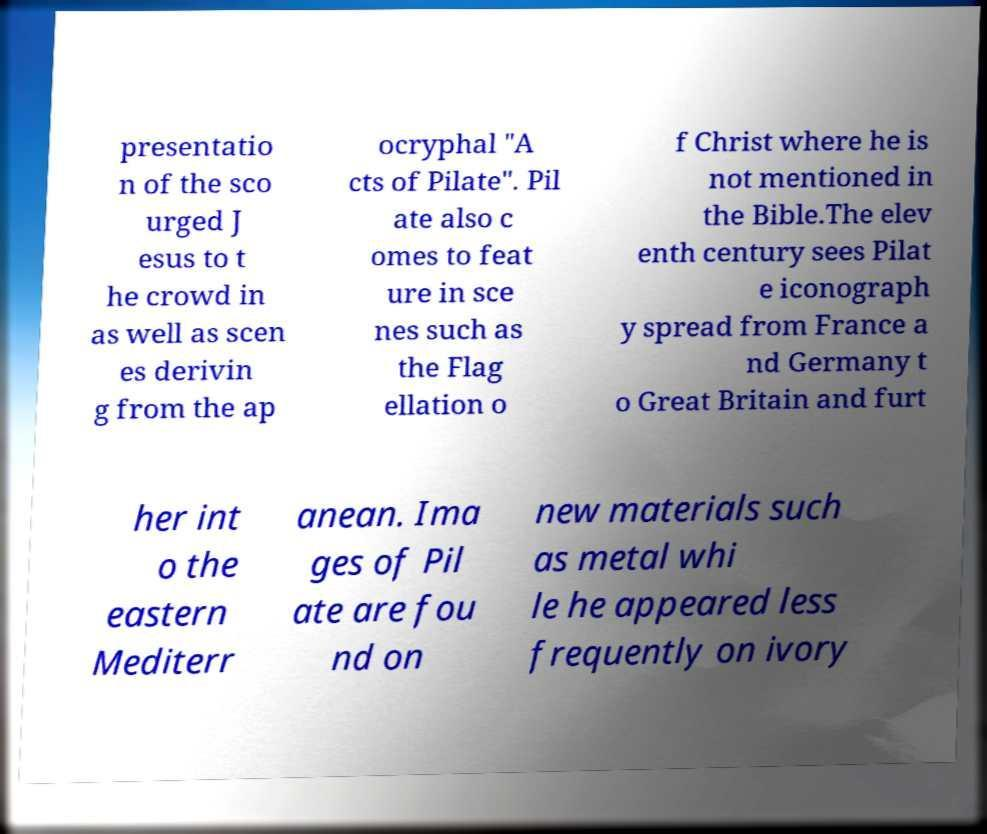Could you extract and type out the text from this image? presentatio n of the sco urged J esus to t he crowd in as well as scen es derivin g from the ap ocryphal "A cts of Pilate". Pil ate also c omes to feat ure in sce nes such as the Flag ellation o f Christ where he is not mentioned in the Bible.The elev enth century sees Pilat e iconograph y spread from France a nd Germany t o Great Britain and furt her int o the eastern Mediterr anean. Ima ges of Pil ate are fou nd on new materials such as metal whi le he appeared less frequently on ivory 